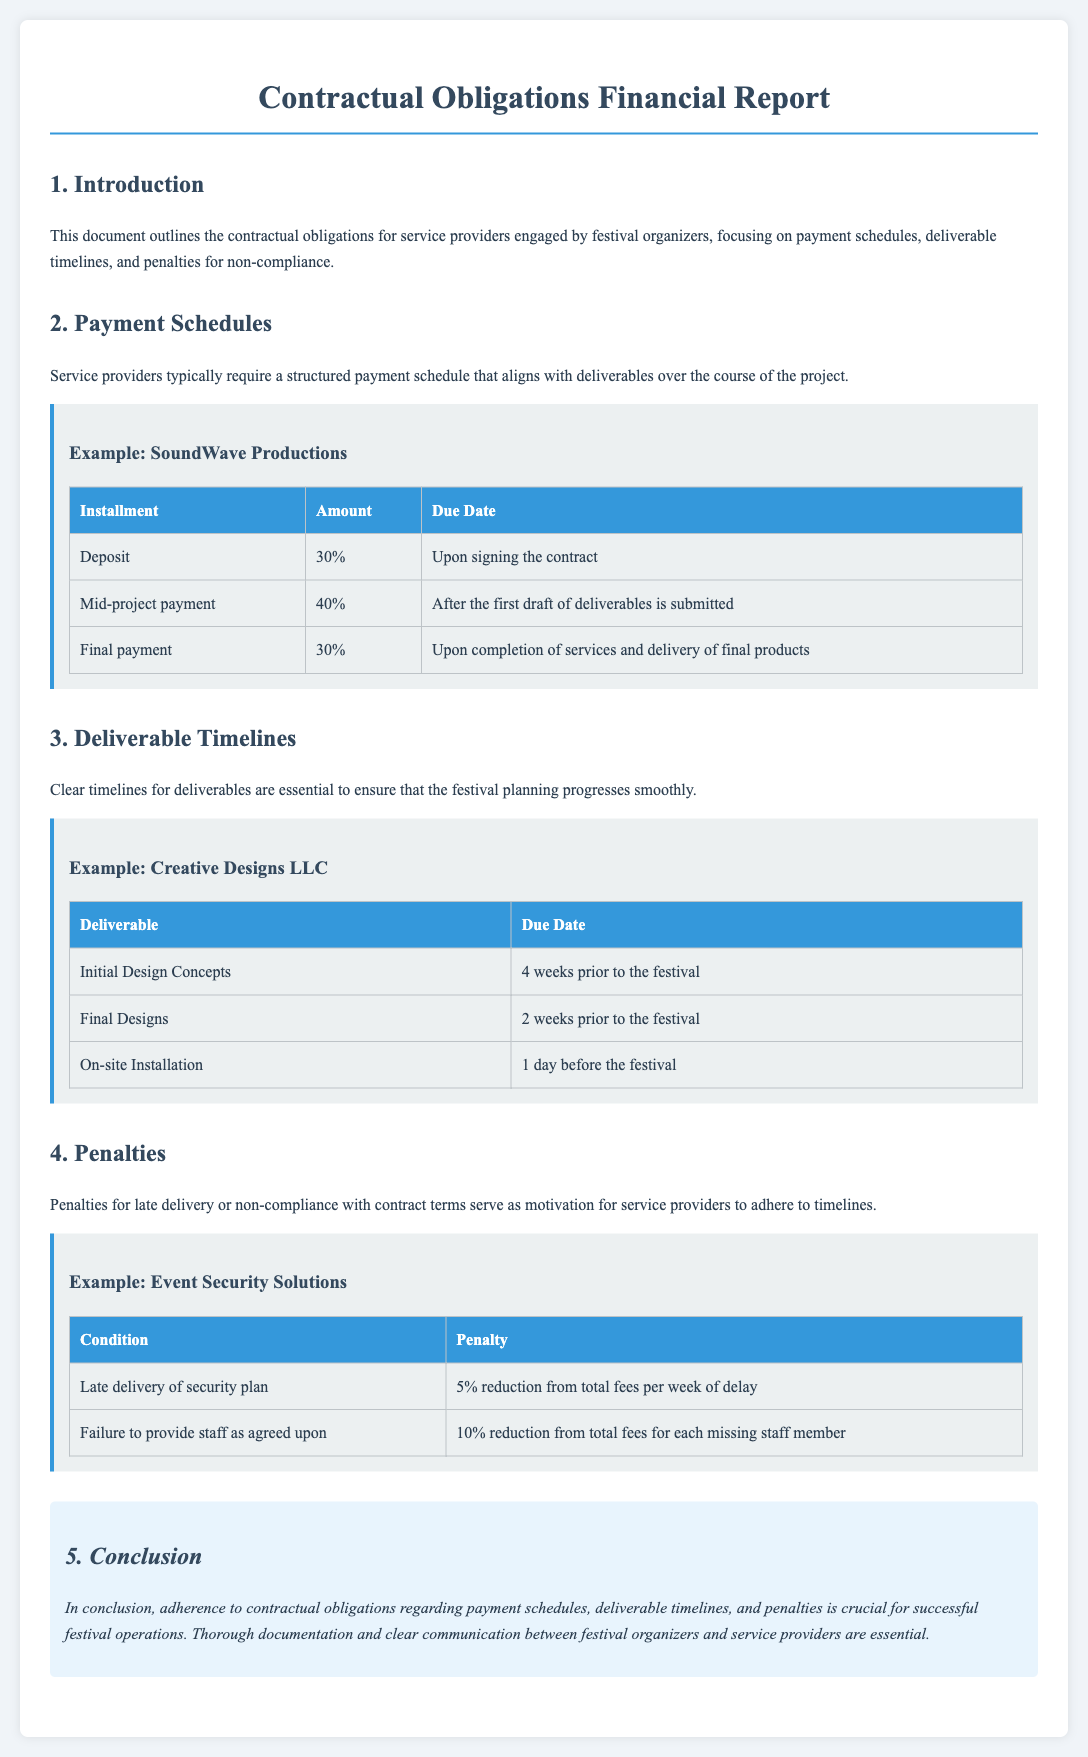What percentage is required as a deposit? The document states that SoundWave Productions requires a 30% deposit upon signing the contract.
Answer: 30% When are the initial design concepts due? Creative Designs LLC has a deadline for the initial design concepts set for 4 weeks prior to the festival.
Answer: 4 weeks prior to the festival What is the penalty for late delivery of a security plan? Event Security Solutions will incur a 5% reduction from total fees for each week of delay in delivering the security plan.
Answer: 5% reduction per week How much do service providers typically request for mid-project payment? According to SoundWave Productions, the mid-project payment is 40% of the total amount after the first draft of deliverables is submitted.
Answer: 40% What is the final payment due condition for SoundWave Productions? The final payment is due upon completion of services and delivery of final products.
Answer: Upon completion of services and delivery of final products What happens if staff is not provided as agreed? The penalty for failure to provide staff is a 10% reduction from total fees for each missing staff member.
Answer: 10% reduction for each missing staff member When is the on-site installation scheduled? Creative Designs LLC is scheduled to complete on-site installation 1 day before the festival.
Answer: 1 day before the festival 